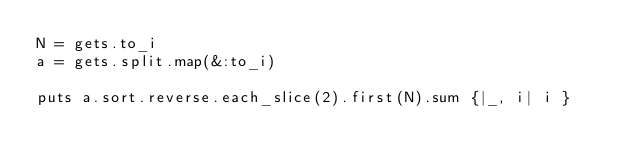Convert code to text. <code><loc_0><loc_0><loc_500><loc_500><_Ruby_>N = gets.to_i
a = gets.split.map(&:to_i)

puts a.sort.reverse.each_slice(2).first(N).sum {|_, i| i }</code> 